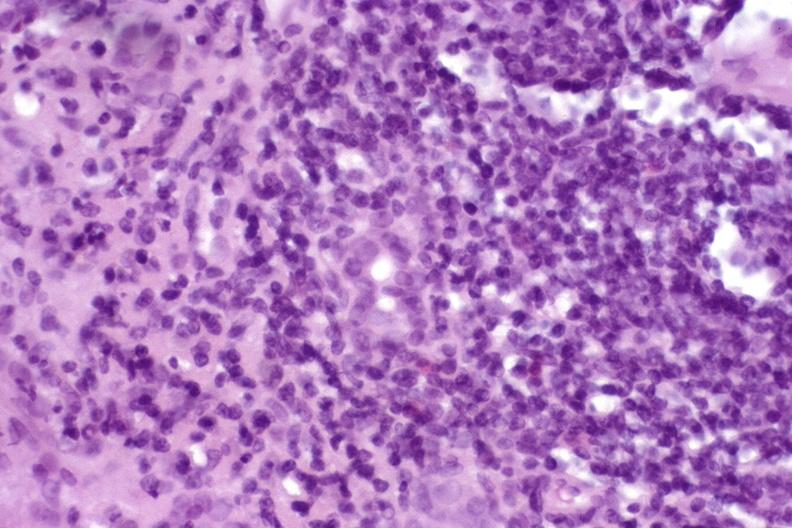what does this image show?
Answer the question using a single word or phrase. Autoimmune hepatitis 